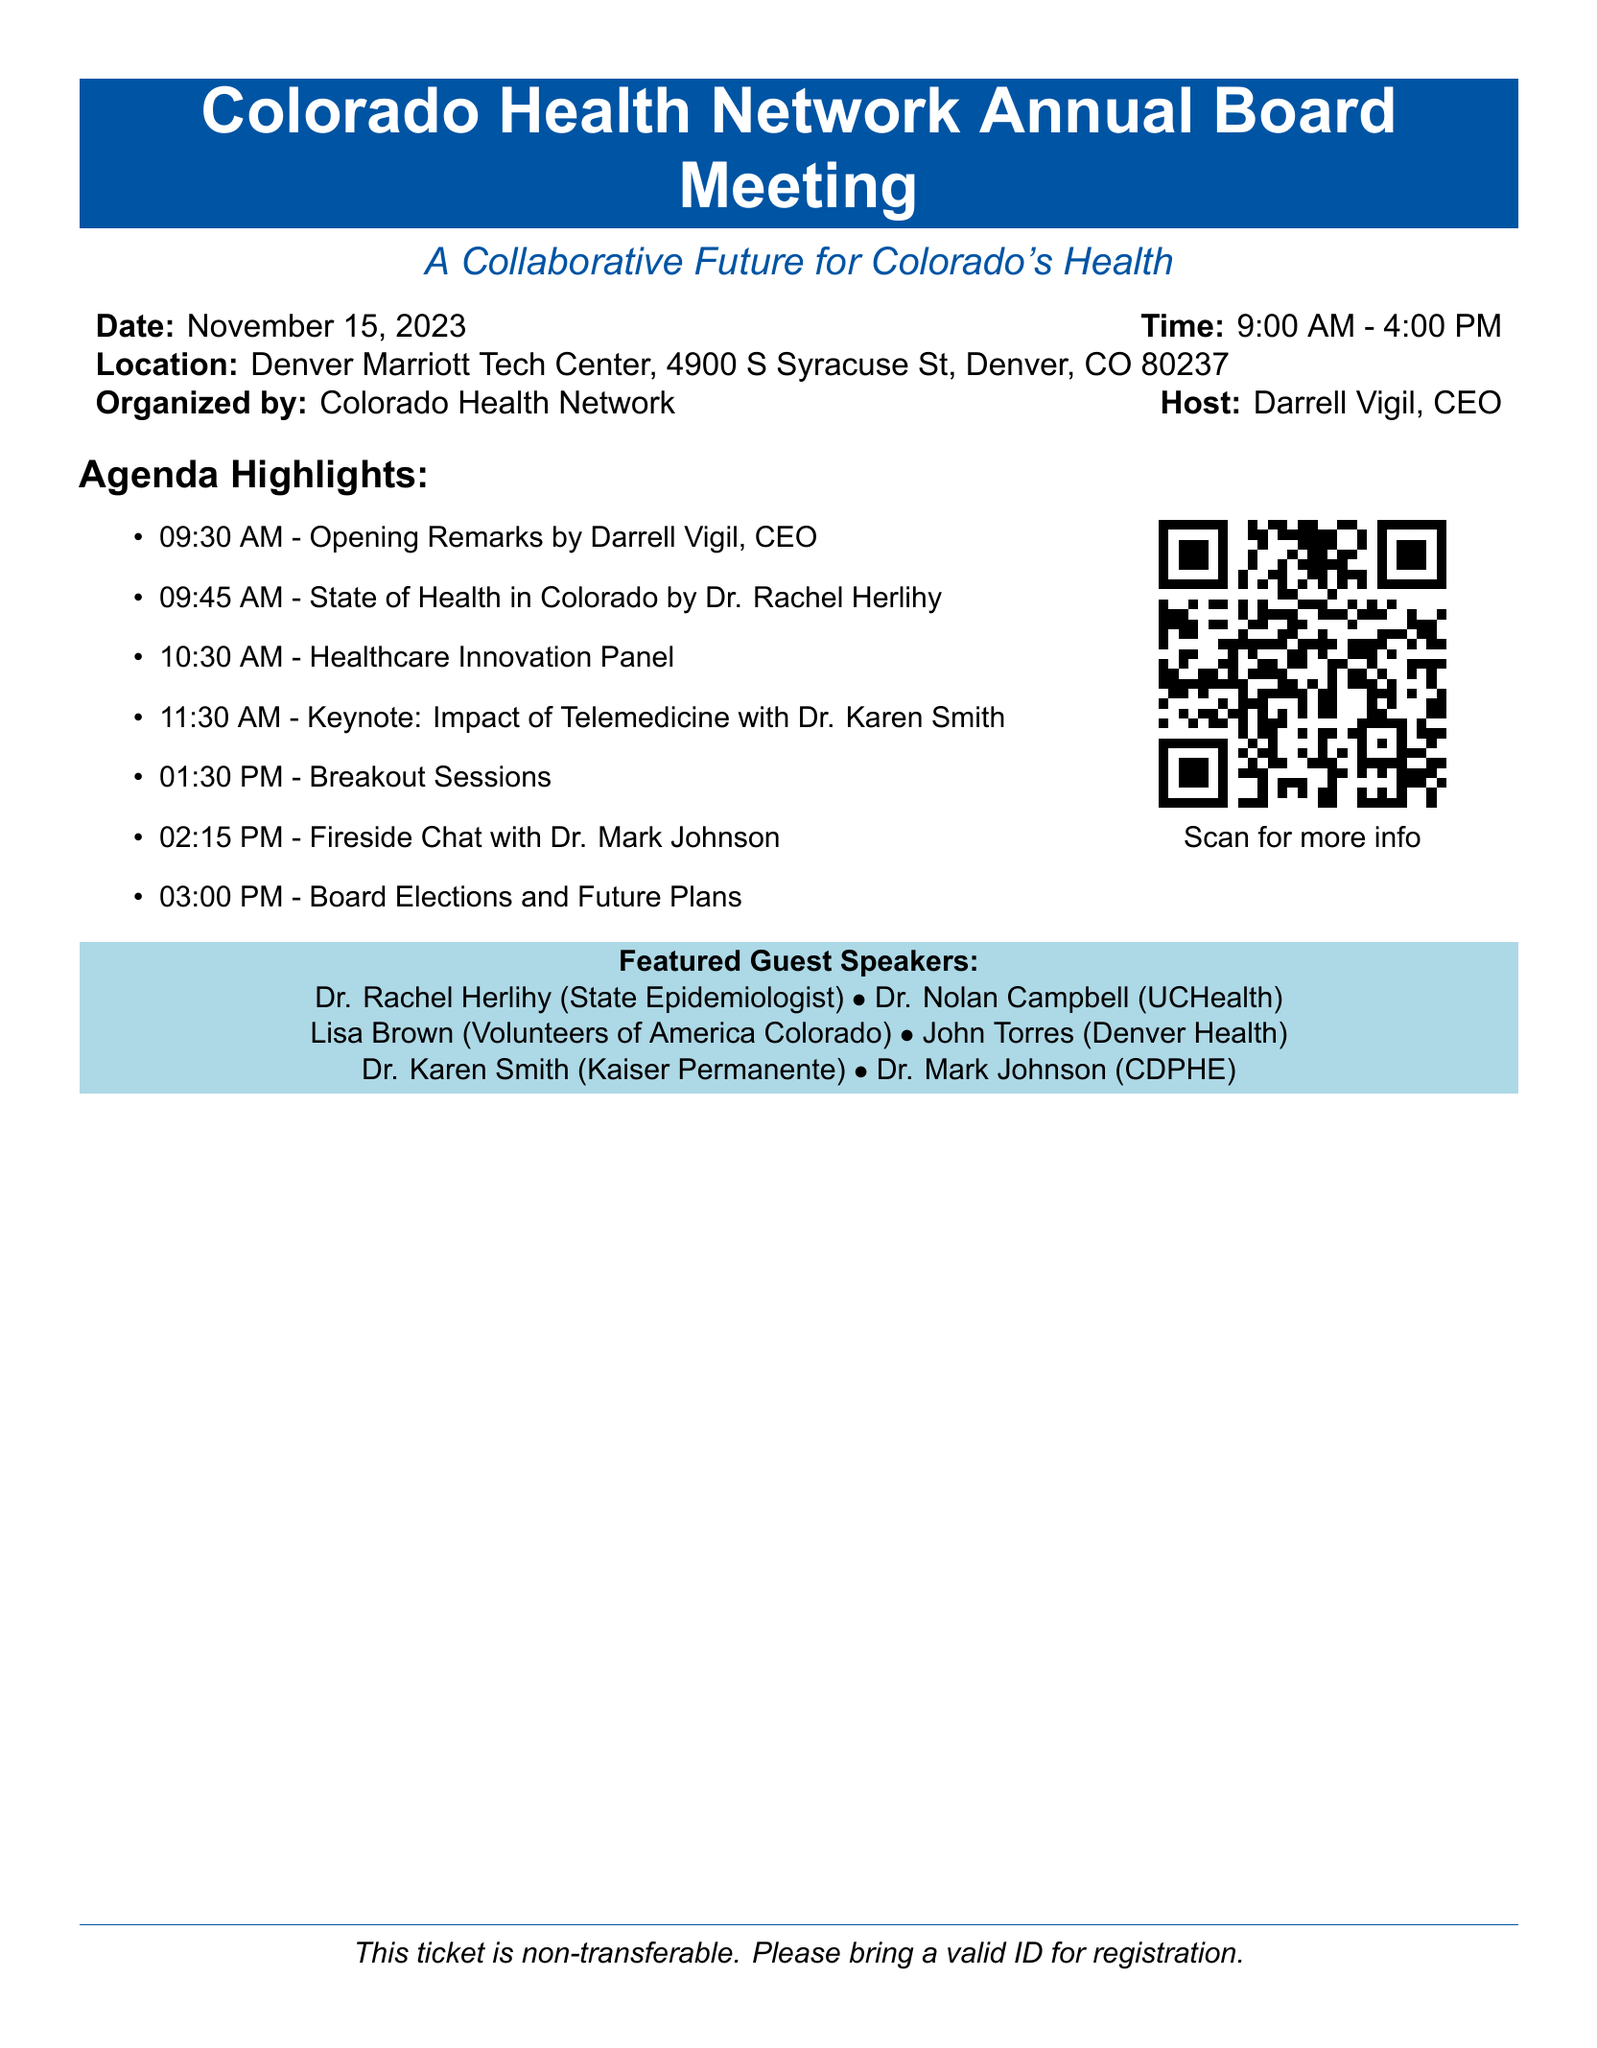What is the date of the meeting? The date of the meeting is specified in the document as November 15, 2023.
Answer: November 15, 2023 Who is the host of the event? The host of the event is mentioned in the document as Darrell Vigil, CEO.
Answer: Darrell Vigil, CEO What is the location of the meeting? The document provides the complete address for the meeting location: Denver Marriott Tech Center, 4900 S Syracuse St, Denver, CO 80237.
Answer: Denver Marriott Tech Center, 4900 S Syracuse St, Denver, CO 80237 What time does the meeting start? The starting time of the meeting is listed in the document, which is 9:00 AM.
Answer: 9:00 AM Who is the keynote speaker? The keynote speaker is identified in the agenda as Dr. Karen Smith.
Answer: Dr. Karen Smith What topic will Dr. Rachel Herlihy discuss? Dr. Rachel Herlihy's topic is specified in the agenda as "State of Health in Colorado."
Answer: State of Health in Colorado How long is the break before breakout sessions? The schedule indicates there is a break from 11:30 AM to 1:30 PM, making it two hours.
Answer: Two hours What type of session starts at 01:30 PM? The agenda lists that "Breakout Sessions" will begin at 01:30 PM.
Answer: Breakout Sessions What are attendees advised to bring for registration? The document notes that attendees should bring a valid ID for registration.
Answer: A valid ID 